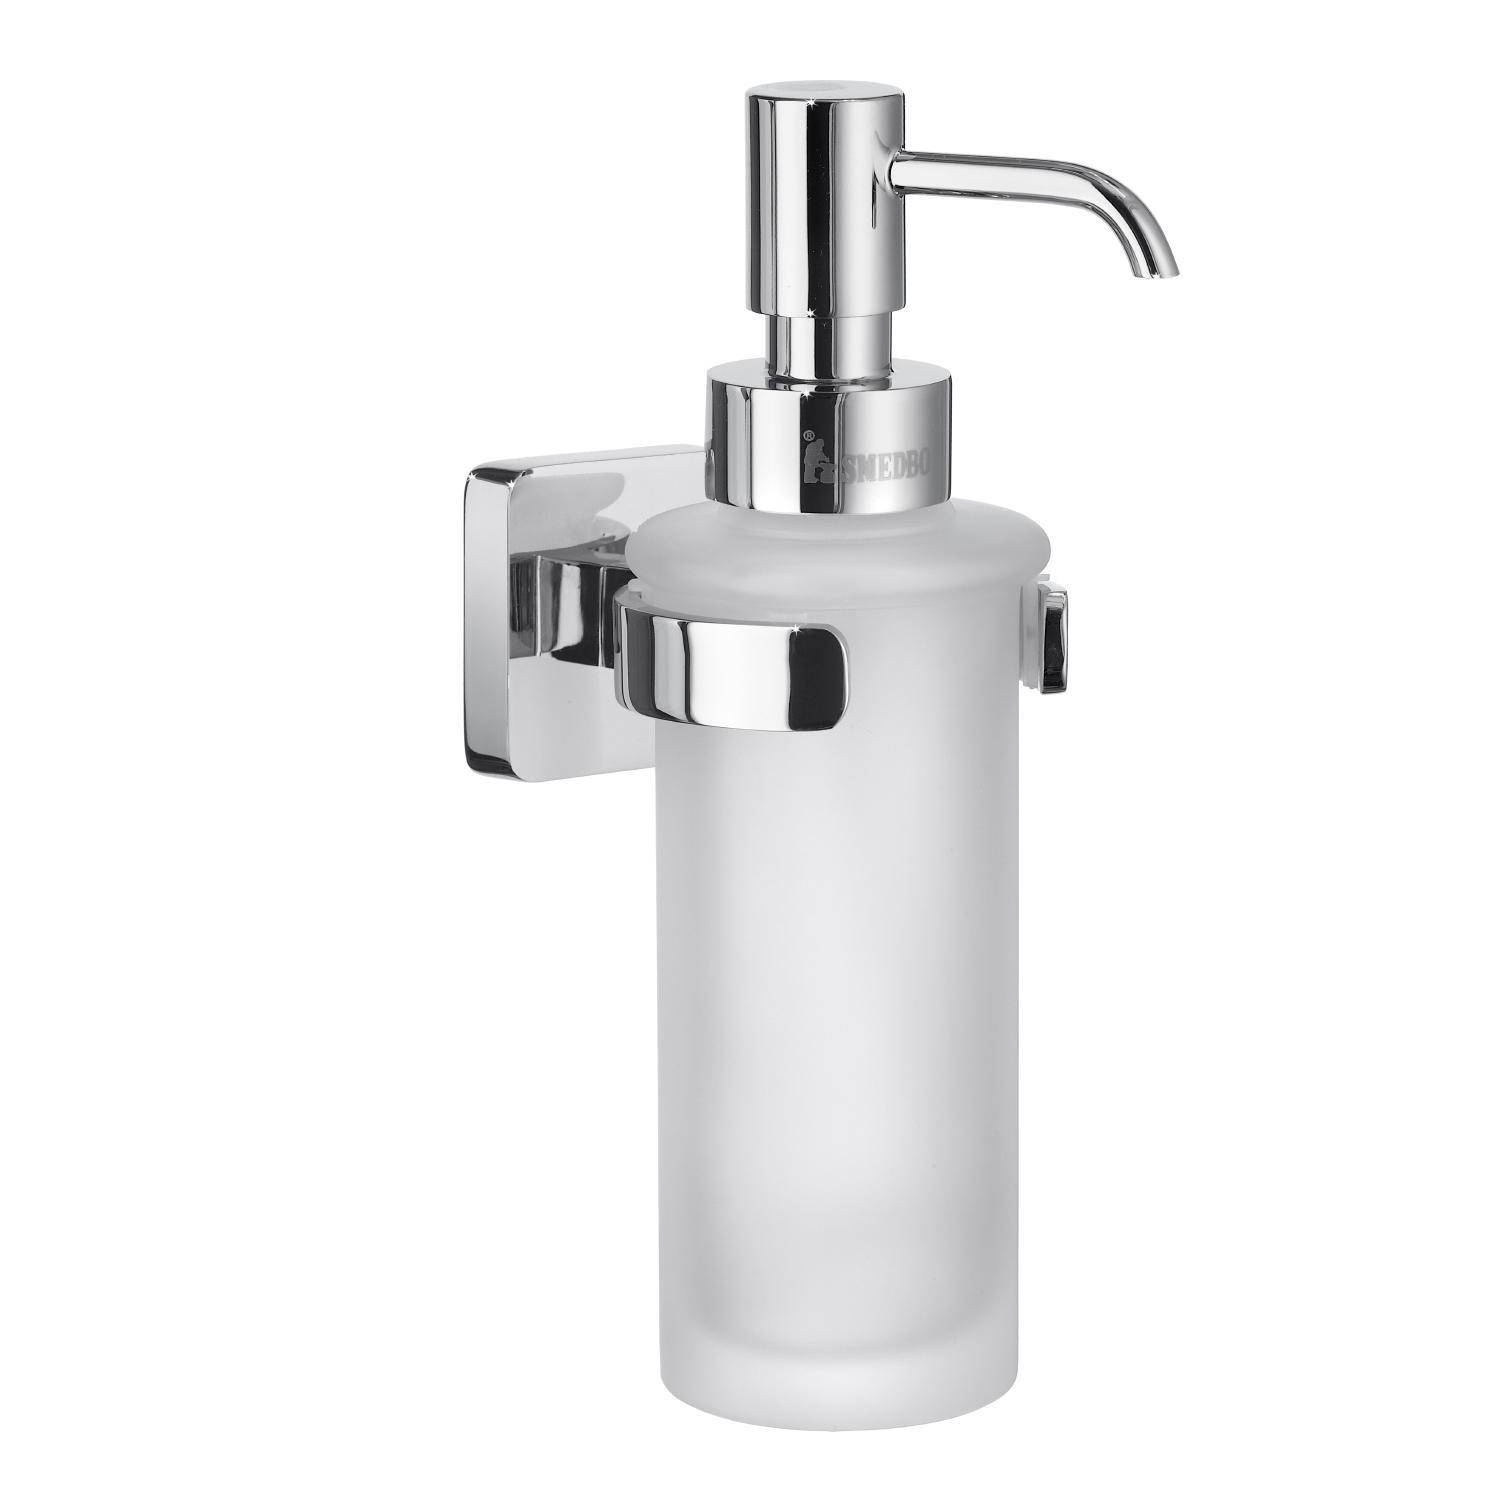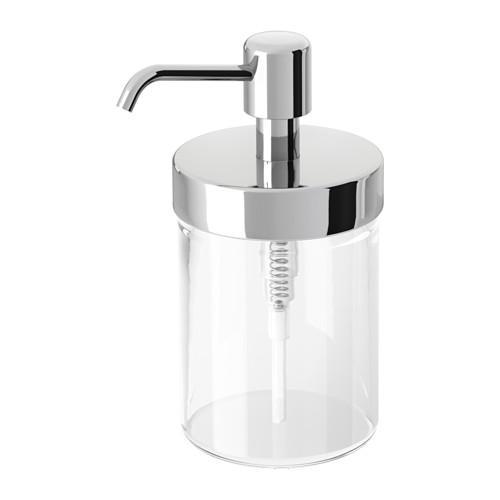The first image is the image on the left, the second image is the image on the right. Assess this claim about the two images: "Both dispensers have silver colored nozzles.". Correct or not? Answer yes or no. Yes. 